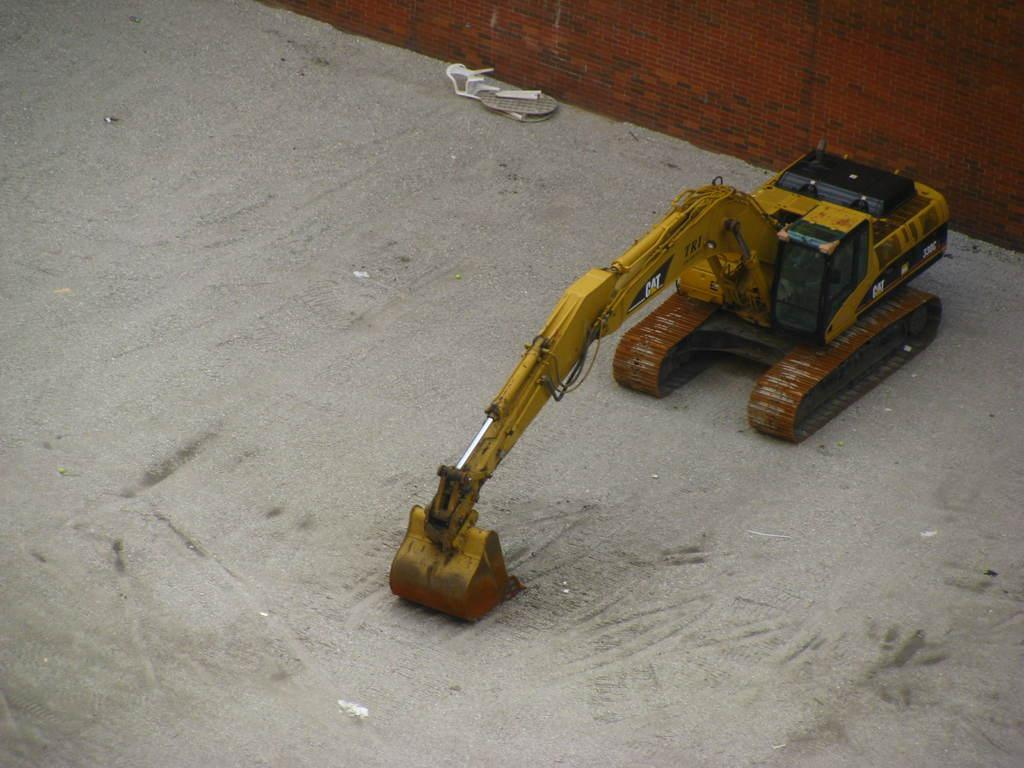What is the primary surface visible in the image? There is a floor in the image. What color is the wall in the image? There is an orange color wall in the image. What type of toy is present in the image? There is a yellow color toy crane in the image. How many sheep can be seen grazing on the floor in the image? There are no sheep present in the image. What type of pollution is visible in the image? There is no pollution visible in the image. 